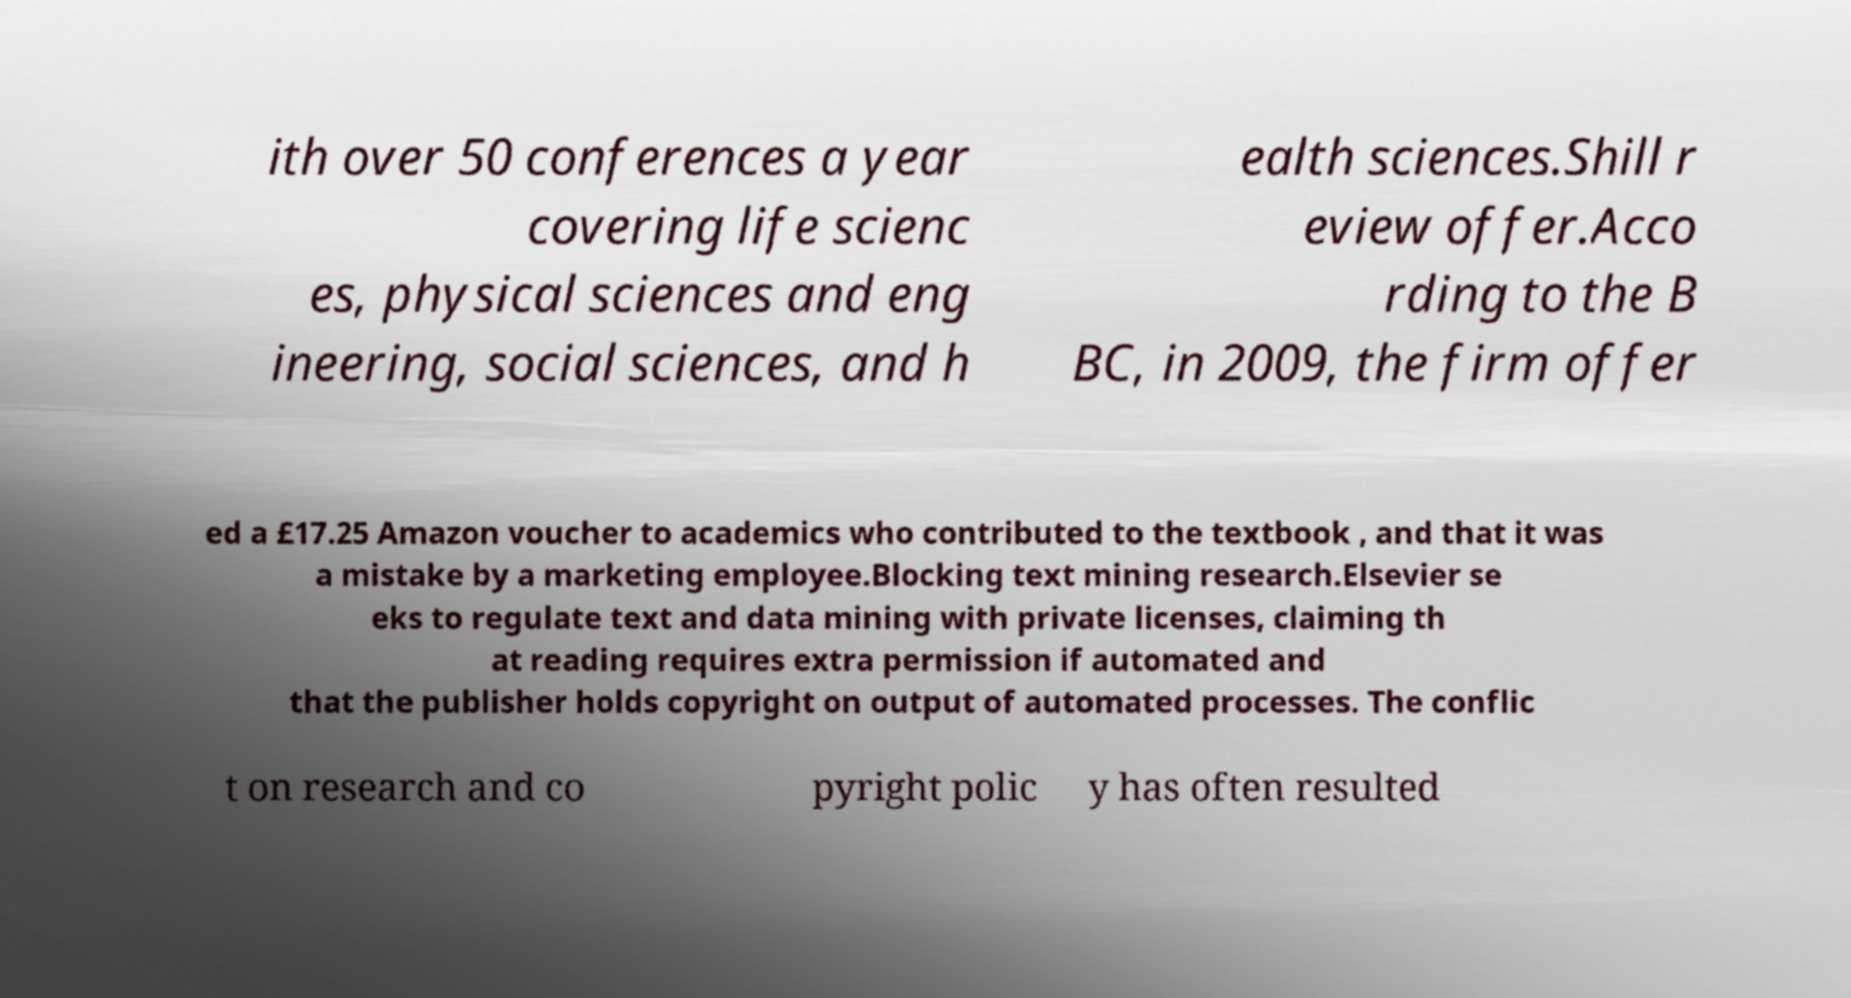What messages or text are displayed in this image? I need them in a readable, typed format. ith over 50 conferences a year covering life scienc es, physical sciences and eng ineering, social sciences, and h ealth sciences.Shill r eview offer.Acco rding to the B BC, in 2009, the firm offer ed a £17.25 Amazon voucher to academics who contributed to the textbook , and that it was a mistake by a marketing employee.Blocking text mining research.Elsevier se eks to regulate text and data mining with private licenses, claiming th at reading requires extra permission if automated and that the publisher holds copyright on output of automated processes. The conflic t on research and co pyright polic y has often resulted 